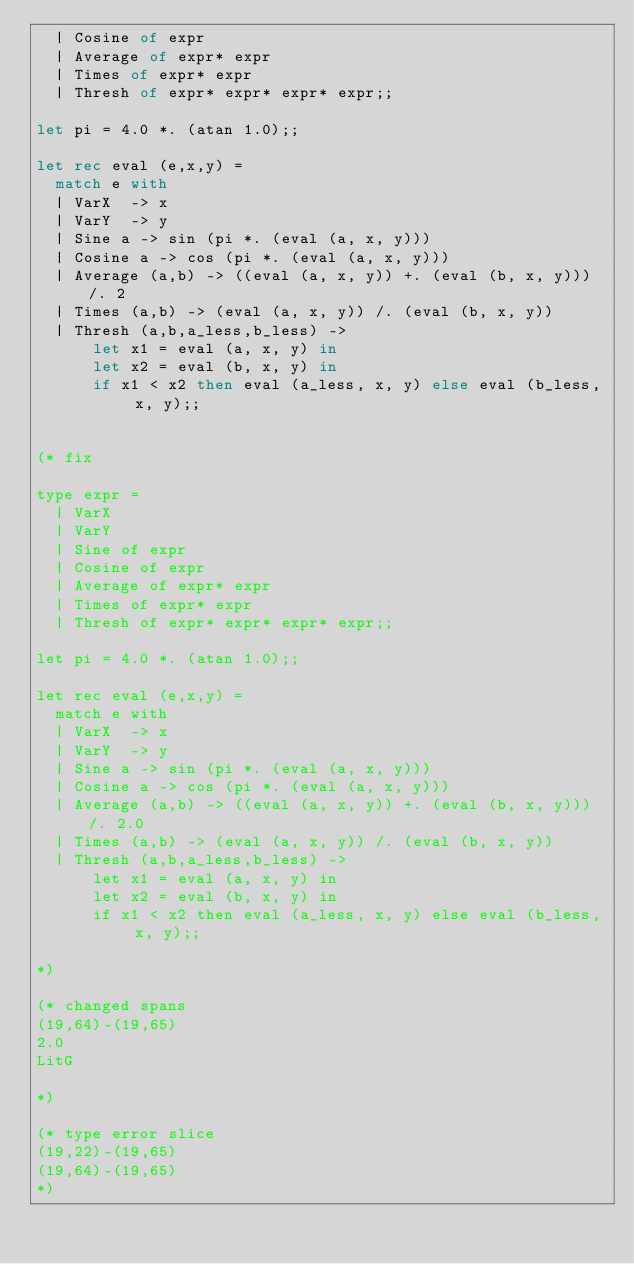<code> <loc_0><loc_0><loc_500><loc_500><_OCaml_>  | Cosine of expr
  | Average of expr* expr
  | Times of expr* expr
  | Thresh of expr* expr* expr* expr;;

let pi = 4.0 *. (atan 1.0);;

let rec eval (e,x,y) =
  match e with
  | VarX  -> x
  | VarY  -> y
  | Sine a -> sin (pi *. (eval (a, x, y)))
  | Cosine a -> cos (pi *. (eval (a, x, y)))
  | Average (a,b) -> ((eval (a, x, y)) +. (eval (b, x, y))) /. 2
  | Times (a,b) -> (eval (a, x, y)) /. (eval (b, x, y))
  | Thresh (a,b,a_less,b_less) ->
      let x1 = eval (a, x, y) in
      let x2 = eval (b, x, y) in
      if x1 < x2 then eval (a_less, x, y) else eval (b_less, x, y);;


(* fix

type expr =
  | VarX
  | VarY
  | Sine of expr
  | Cosine of expr
  | Average of expr* expr
  | Times of expr* expr
  | Thresh of expr* expr* expr* expr;;

let pi = 4.0 *. (atan 1.0);;

let rec eval (e,x,y) =
  match e with
  | VarX  -> x
  | VarY  -> y
  | Sine a -> sin (pi *. (eval (a, x, y)))
  | Cosine a -> cos (pi *. (eval (a, x, y)))
  | Average (a,b) -> ((eval (a, x, y)) +. (eval (b, x, y))) /. 2.0
  | Times (a,b) -> (eval (a, x, y)) /. (eval (b, x, y))
  | Thresh (a,b,a_less,b_less) ->
      let x1 = eval (a, x, y) in
      let x2 = eval (b, x, y) in
      if x1 < x2 then eval (a_less, x, y) else eval (b_less, x, y);;

*)

(* changed spans
(19,64)-(19,65)
2.0
LitG

*)

(* type error slice
(19,22)-(19,65)
(19,64)-(19,65)
*)
</code> 